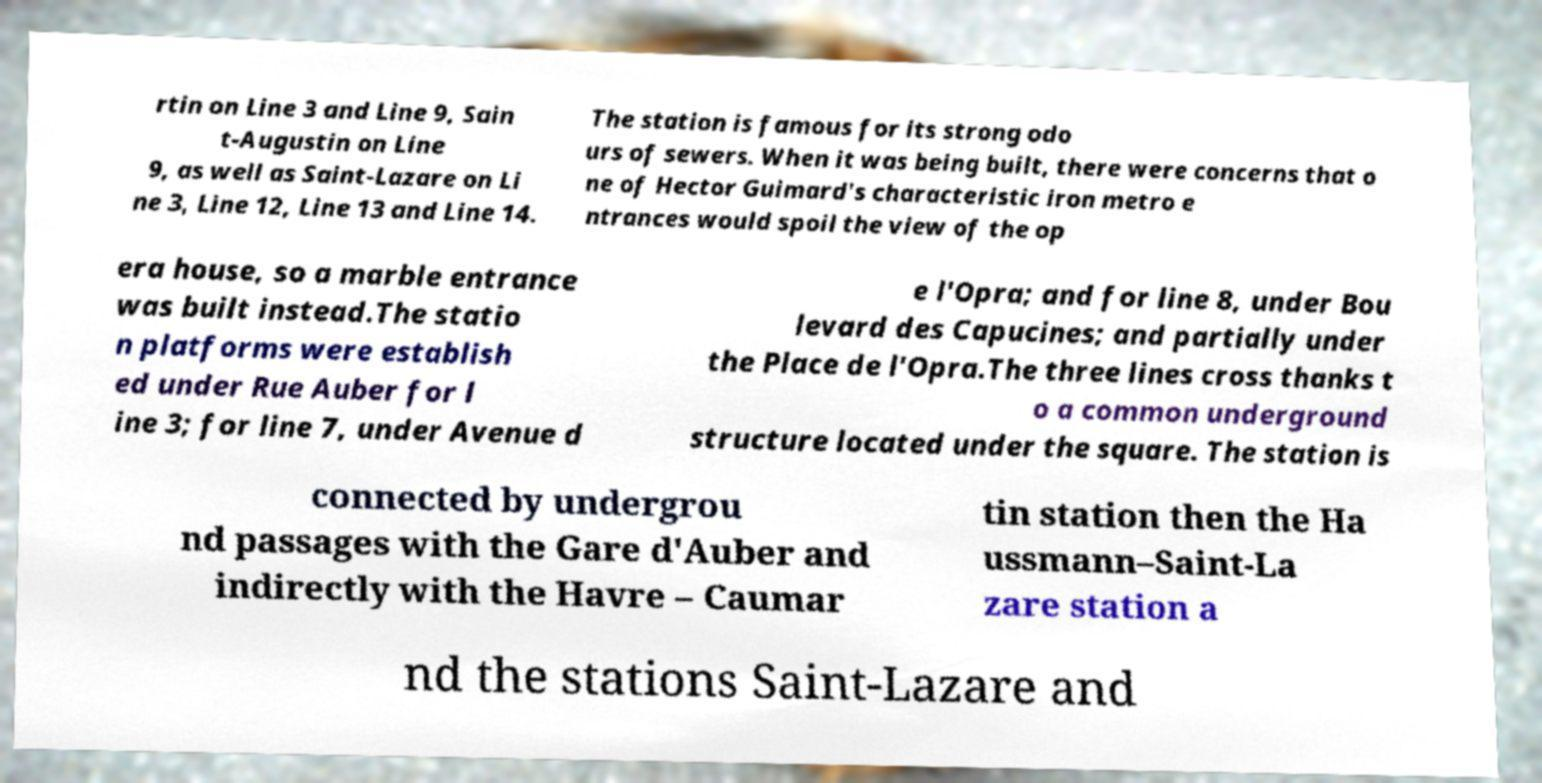Please read and relay the text visible in this image. What does it say? rtin on Line 3 and Line 9, Sain t-Augustin on Line 9, as well as Saint-Lazare on Li ne 3, Line 12, Line 13 and Line 14. The station is famous for its strong odo urs of sewers. When it was being built, there were concerns that o ne of Hector Guimard's characteristic iron metro e ntrances would spoil the view of the op era house, so a marble entrance was built instead.The statio n platforms were establish ed under Rue Auber for l ine 3; for line 7, under Avenue d e l'Opra; and for line 8, under Bou levard des Capucines; and partially under the Place de l'Opra.The three lines cross thanks t o a common underground structure located under the square. The station is connected by undergrou nd passages with the Gare d'Auber and indirectly with the Havre – Caumar tin station then the Ha ussmann–Saint-La zare station a nd the stations Saint-Lazare and 